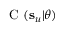<formula> <loc_0><loc_0><loc_500><loc_500>C ( s _ { u } | \theta )</formula> 